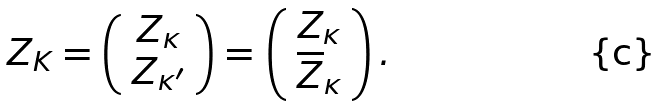Convert formula to latex. <formula><loc_0><loc_0><loc_500><loc_500>Z _ { K } = \left ( \begin{array} { c } Z _ { \kappa } \\ Z _ { \kappa ^ { \prime } } \end{array} \right ) = & \, \left ( \begin{array} { c } Z _ { \kappa } \\ \overline { Z } _ { \kappa } \end{array} \right ) .</formula> 